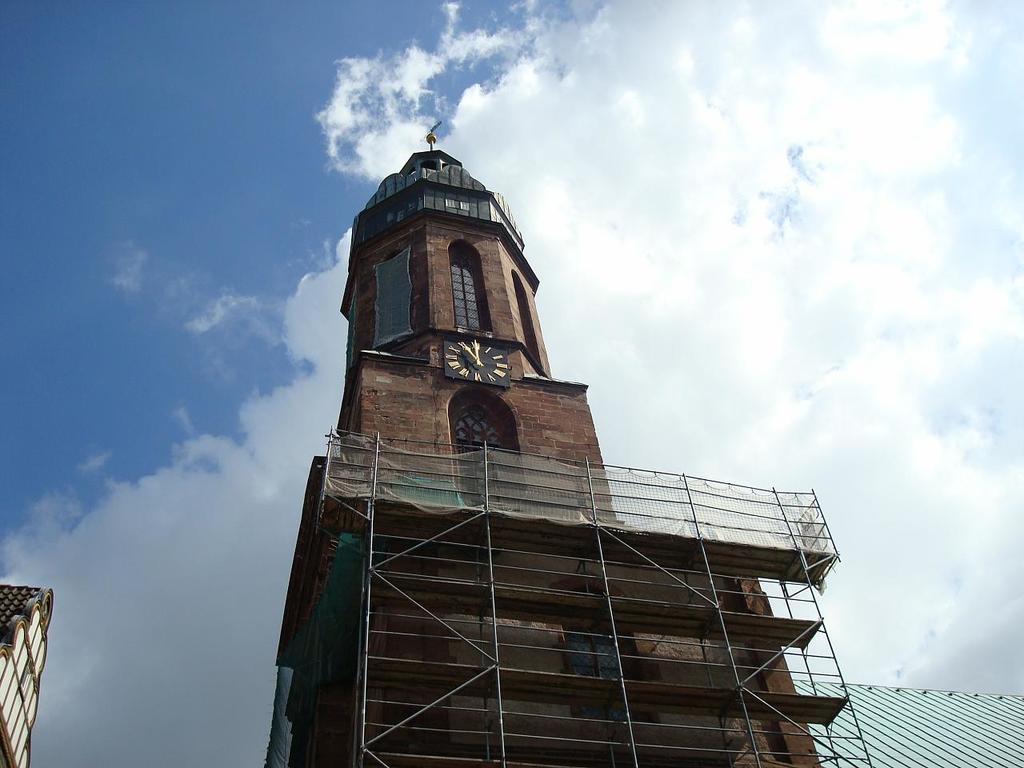What type of structure is visible in the image? There is a building in the image. What else can be seen in the image besides the building? There are other objects in the image. Can you describe the object located on the left side of the image? There is an object on the left side of the image, but its specific details are not mentioned in the provided facts. What is visible in the background of the image? The sky is visible in the background of the image. How many toes are visible on the building in the image? There are no toes present in the image, as it features a building and other objects, not people or animals. 